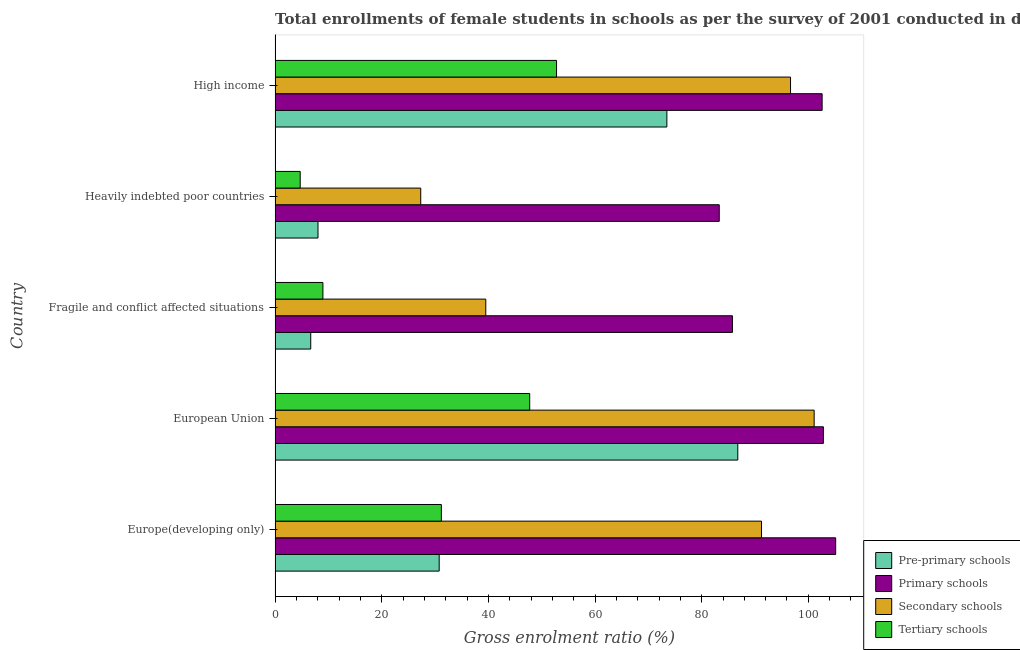How many different coloured bars are there?
Give a very brief answer. 4. How many bars are there on the 2nd tick from the top?
Keep it short and to the point. 4. What is the label of the 1st group of bars from the top?
Your answer should be very brief. High income. What is the gross enrolment ratio(female) in primary schools in Heavily indebted poor countries?
Provide a succinct answer. 83.3. Across all countries, what is the maximum gross enrolment ratio(female) in primary schools?
Give a very brief answer. 105.13. Across all countries, what is the minimum gross enrolment ratio(female) in tertiary schools?
Give a very brief answer. 4.71. In which country was the gross enrolment ratio(female) in primary schools minimum?
Give a very brief answer. Heavily indebted poor countries. What is the total gross enrolment ratio(female) in pre-primary schools in the graph?
Your response must be concise. 205.76. What is the difference between the gross enrolment ratio(female) in pre-primary schools in Fragile and conflict affected situations and that in Heavily indebted poor countries?
Offer a very short reply. -1.36. What is the difference between the gross enrolment ratio(female) in pre-primary schools in Heavily indebted poor countries and the gross enrolment ratio(female) in primary schools in European Union?
Your response must be concise. -94.78. What is the average gross enrolment ratio(female) in secondary schools per country?
Offer a very short reply. 71.16. What is the difference between the gross enrolment ratio(female) in primary schools and gross enrolment ratio(female) in pre-primary schools in Fragile and conflict affected situations?
Ensure brevity in your answer.  79.08. In how many countries, is the gross enrolment ratio(female) in primary schools greater than 88 %?
Make the answer very short. 3. What is the ratio of the gross enrolment ratio(female) in primary schools in Europe(developing only) to that in Fragile and conflict affected situations?
Your answer should be compact. 1.23. Is the gross enrolment ratio(female) in pre-primary schools in European Union less than that in Fragile and conflict affected situations?
Offer a very short reply. No. Is the difference between the gross enrolment ratio(female) in tertiary schools in Heavily indebted poor countries and High income greater than the difference between the gross enrolment ratio(female) in pre-primary schools in Heavily indebted poor countries and High income?
Offer a very short reply. Yes. What is the difference between the highest and the second highest gross enrolment ratio(female) in tertiary schools?
Give a very brief answer. 5.03. What is the difference between the highest and the lowest gross enrolment ratio(female) in pre-primary schools?
Ensure brevity in your answer.  80.09. Is the sum of the gross enrolment ratio(female) in primary schools in Fragile and conflict affected situations and Heavily indebted poor countries greater than the maximum gross enrolment ratio(female) in pre-primary schools across all countries?
Give a very brief answer. Yes. Is it the case that in every country, the sum of the gross enrolment ratio(female) in secondary schools and gross enrolment ratio(female) in primary schools is greater than the sum of gross enrolment ratio(female) in tertiary schools and gross enrolment ratio(female) in pre-primary schools?
Your answer should be compact. Yes. What does the 2nd bar from the top in Fragile and conflict affected situations represents?
Your answer should be compact. Secondary schools. What does the 2nd bar from the bottom in High income represents?
Keep it short and to the point. Primary schools. Are all the bars in the graph horizontal?
Provide a short and direct response. Yes. What is the difference between two consecutive major ticks on the X-axis?
Keep it short and to the point. 20. Are the values on the major ticks of X-axis written in scientific E-notation?
Offer a very short reply. No. Does the graph contain any zero values?
Provide a short and direct response. No. Does the graph contain grids?
Ensure brevity in your answer.  No. How are the legend labels stacked?
Your answer should be compact. Vertical. What is the title of the graph?
Offer a very short reply. Total enrollments of female students in schools as per the survey of 2001 conducted in different countries. Does "UNHCR" appear as one of the legend labels in the graph?
Offer a very short reply. No. What is the label or title of the X-axis?
Your answer should be very brief. Gross enrolment ratio (%). What is the Gross enrolment ratio (%) of Pre-primary schools in Europe(developing only)?
Give a very brief answer. 30.78. What is the Gross enrolment ratio (%) of Primary schools in Europe(developing only)?
Offer a terse response. 105.13. What is the Gross enrolment ratio (%) of Secondary schools in Europe(developing only)?
Make the answer very short. 91.22. What is the Gross enrolment ratio (%) of Tertiary schools in Europe(developing only)?
Provide a succinct answer. 31.18. What is the Gross enrolment ratio (%) of Pre-primary schools in European Union?
Give a very brief answer. 86.77. What is the Gross enrolment ratio (%) in Primary schools in European Union?
Offer a terse response. 102.83. What is the Gross enrolment ratio (%) of Secondary schools in European Union?
Your answer should be compact. 101.09. What is the Gross enrolment ratio (%) of Tertiary schools in European Union?
Offer a very short reply. 47.75. What is the Gross enrolment ratio (%) in Pre-primary schools in Fragile and conflict affected situations?
Your response must be concise. 6.69. What is the Gross enrolment ratio (%) in Primary schools in Fragile and conflict affected situations?
Offer a very short reply. 85.77. What is the Gross enrolment ratio (%) in Secondary schools in Fragile and conflict affected situations?
Your answer should be very brief. 39.51. What is the Gross enrolment ratio (%) in Tertiary schools in Fragile and conflict affected situations?
Offer a very short reply. 8.97. What is the Gross enrolment ratio (%) in Pre-primary schools in Heavily indebted poor countries?
Offer a very short reply. 8.05. What is the Gross enrolment ratio (%) of Primary schools in Heavily indebted poor countries?
Your response must be concise. 83.3. What is the Gross enrolment ratio (%) of Secondary schools in Heavily indebted poor countries?
Make the answer very short. 27.31. What is the Gross enrolment ratio (%) in Tertiary schools in Heavily indebted poor countries?
Make the answer very short. 4.71. What is the Gross enrolment ratio (%) of Pre-primary schools in High income?
Offer a very short reply. 73.47. What is the Gross enrolment ratio (%) in Primary schools in High income?
Provide a short and direct response. 102.59. What is the Gross enrolment ratio (%) in Secondary schools in High income?
Provide a succinct answer. 96.66. What is the Gross enrolment ratio (%) in Tertiary schools in High income?
Make the answer very short. 52.78. Across all countries, what is the maximum Gross enrolment ratio (%) of Pre-primary schools?
Ensure brevity in your answer.  86.77. Across all countries, what is the maximum Gross enrolment ratio (%) in Primary schools?
Your answer should be very brief. 105.13. Across all countries, what is the maximum Gross enrolment ratio (%) in Secondary schools?
Provide a succinct answer. 101.09. Across all countries, what is the maximum Gross enrolment ratio (%) of Tertiary schools?
Offer a very short reply. 52.78. Across all countries, what is the minimum Gross enrolment ratio (%) of Pre-primary schools?
Your answer should be very brief. 6.69. Across all countries, what is the minimum Gross enrolment ratio (%) of Primary schools?
Provide a short and direct response. 83.3. Across all countries, what is the minimum Gross enrolment ratio (%) of Secondary schools?
Keep it short and to the point. 27.31. Across all countries, what is the minimum Gross enrolment ratio (%) of Tertiary schools?
Your response must be concise. 4.71. What is the total Gross enrolment ratio (%) of Pre-primary schools in the graph?
Make the answer very short. 205.76. What is the total Gross enrolment ratio (%) of Primary schools in the graph?
Give a very brief answer. 479.61. What is the total Gross enrolment ratio (%) in Secondary schools in the graph?
Keep it short and to the point. 355.81. What is the total Gross enrolment ratio (%) in Tertiary schools in the graph?
Ensure brevity in your answer.  145.4. What is the difference between the Gross enrolment ratio (%) of Pre-primary schools in Europe(developing only) and that in European Union?
Your answer should be very brief. -56. What is the difference between the Gross enrolment ratio (%) of Primary schools in Europe(developing only) and that in European Union?
Your answer should be very brief. 2.3. What is the difference between the Gross enrolment ratio (%) in Secondary schools in Europe(developing only) and that in European Union?
Give a very brief answer. -9.87. What is the difference between the Gross enrolment ratio (%) of Tertiary schools in Europe(developing only) and that in European Union?
Offer a terse response. -16.57. What is the difference between the Gross enrolment ratio (%) in Pre-primary schools in Europe(developing only) and that in Fragile and conflict affected situations?
Your answer should be compact. 24.09. What is the difference between the Gross enrolment ratio (%) of Primary schools in Europe(developing only) and that in Fragile and conflict affected situations?
Keep it short and to the point. 19.36. What is the difference between the Gross enrolment ratio (%) of Secondary schools in Europe(developing only) and that in Fragile and conflict affected situations?
Provide a short and direct response. 51.71. What is the difference between the Gross enrolment ratio (%) in Tertiary schools in Europe(developing only) and that in Fragile and conflict affected situations?
Give a very brief answer. 22.21. What is the difference between the Gross enrolment ratio (%) of Pre-primary schools in Europe(developing only) and that in Heavily indebted poor countries?
Your answer should be compact. 22.73. What is the difference between the Gross enrolment ratio (%) of Primary schools in Europe(developing only) and that in Heavily indebted poor countries?
Your response must be concise. 21.83. What is the difference between the Gross enrolment ratio (%) in Secondary schools in Europe(developing only) and that in Heavily indebted poor countries?
Ensure brevity in your answer.  63.91. What is the difference between the Gross enrolment ratio (%) of Tertiary schools in Europe(developing only) and that in Heavily indebted poor countries?
Make the answer very short. 26.47. What is the difference between the Gross enrolment ratio (%) of Pre-primary schools in Europe(developing only) and that in High income?
Your response must be concise. -42.7. What is the difference between the Gross enrolment ratio (%) in Primary schools in Europe(developing only) and that in High income?
Keep it short and to the point. 2.54. What is the difference between the Gross enrolment ratio (%) of Secondary schools in Europe(developing only) and that in High income?
Offer a terse response. -5.44. What is the difference between the Gross enrolment ratio (%) of Tertiary schools in Europe(developing only) and that in High income?
Give a very brief answer. -21.6. What is the difference between the Gross enrolment ratio (%) in Pre-primary schools in European Union and that in Fragile and conflict affected situations?
Your answer should be compact. 80.09. What is the difference between the Gross enrolment ratio (%) in Primary schools in European Union and that in Fragile and conflict affected situations?
Provide a succinct answer. 17.06. What is the difference between the Gross enrolment ratio (%) in Secondary schools in European Union and that in Fragile and conflict affected situations?
Give a very brief answer. 61.58. What is the difference between the Gross enrolment ratio (%) of Tertiary schools in European Union and that in Fragile and conflict affected situations?
Ensure brevity in your answer.  38.78. What is the difference between the Gross enrolment ratio (%) of Pre-primary schools in European Union and that in Heavily indebted poor countries?
Provide a succinct answer. 78.72. What is the difference between the Gross enrolment ratio (%) of Primary schools in European Union and that in Heavily indebted poor countries?
Provide a short and direct response. 19.53. What is the difference between the Gross enrolment ratio (%) in Secondary schools in European Union and that in Heavily indebted poor countries?
Offer a terse response. 73.78. What is the difference between the Gross enrolment ratio (%) of Tertiary schools in European Union and that in Heavily indebted poor countries?
Keep it short and to the point. 43.04. What is the difference between the Gross enrolment ratio (%) of Pre-primary schools in European Union and that in High income?
Provide a short and direct response. 13.3. What is the difference between the Gross enrolment ratio (%) of Primary schools in European Union and that in High income?
Your answer should be compact. 0.24. What is the difference between the Gross enrolment ratio (%) in Secondary schools in European Union and that in High income?
Your answer should be very brief. 4.43. What is the difference between the Gross enrolment ratio (%) in Tertiary schools in European Union and that in High income?
Your answer should be compact. -5.03. What is the difference between the Gross enrolment ratio (%) of Pre-primary schools in Fragile and conflict affected situations and that in Heavily indebted poor countries?
Your response must be concise. -1.36. What is the difference between the Gross enrolment ratio (%) of Primary schools in Fragile and conflict affected situations and that in Heavily indebted poor countries?
Offer a terse response. 2.47. What is the difference between the Gross enrolment ratio (%) of Secondary schools in Fragile and conflict affected situations and that in Heavily indebted poor countries?
Give a very brief answer. 12.2. What is the difference between the Gross enrolment ratio (%) of Tertiary schools in Fragile and conflict affected situations and that in Heavily indebted poor countries?
Offer a very short reply. 4.26. What is the difference between the Gross enrolment ratio (%) of Pre-primary schools in Fragile and conflict affected situations and that in High income?
Keep it short and to the point. -66.79. What is the difference between the Gross enrolment ratio (%) in Primary schools in Fragile and conflict affected situations and that in High income?
Provide a succinct answer. -16.82. What is the difference between the Gross enrolment ratio (%) of Secondary schools in Fragile and conflict affected situations and that in High income?
Your answer should be very brief. -57.15. What is the difference between the Gross enrolment ratio (%) of Tertiary schools in Fragile and conflict affected situations and that in High income?
Provide a succinct answer. -43.81. What is the difference between the Gross enrolment ratio (%) of Pre-primary schools in Heavily indebted poor countries and that in High income?
Offer a terse response. -65.43. What is the difference between the Gross enrolment ratio (%) in Primary schools in Heavily indebted poor countries and that in High income?
Your answer should be compact. -19.29. What is the difference between the Gross enrolment ratio (%) of Secondary schools in Heavily indebted poor countries and that in High income?
Your response must be concise. -69.35. What is the difference between the Gross enrolment ratio (%) in Tertiary schools in Heavily indebted poor countries and that in High income?
Your response must be concise. -48.07. What is the difference between the Gross enrolment ratio (%) in Pre-primary schools in Europe(developing only) and the Gross enrolment ratio (%) in Primary schools in European Union?
Your response must be concise. -72.05. What is the difference between the Gross enrolment ratio (%) in Pre-primary schools in Europe(developing only) and the Gross enrolment ratio (%) in Secondary schools in European Union?
Make the answer very short. -70.32. What is the difference between the Gross enrolment ratio (%) in Pre-primary schools in Europe(developing only) and the Gross enrolment ratio (%) in Tertiary schools in European Union?
Provide a short and direct response. -16.98. What is the difference between the Gross enrolment ratio (%) of Primary schools in Europe(developing only) and the Gross enrolment ratio (%) of Secondary schools in European Union?
Give a very brief answer. 4.03. What is the difference between the Gross enrolment ratio (%) of Primary schools in Europe(developing only) and the Gross enrolment ratio (%) of Tertiary schools in European Union?
Provide a succinct answer. 57.38. What is the difference between the Gross enrolment ratio (%) of Secondary schools in Europe(developing only) and the Gross enrolment ratio (%) of Tertiary schools in European Union?
Provide a succinct answer. 43.47. What is the difference between the Gross enrolment ratio (%) of Pre-primary schools in Europe(developing only) and the Gross enrolment ratio (%) of Primary schools in Fragile and conflict affected situations?
Provide a short and direct response. -54.99. What is the difference between the Gross enrolment ratio (%) of Pre-primary schools in Europe(developing only) and the Gross enrolment ratio (%) of Secondary schools in Fragile and conflict affected situations?
Make the answer very short. -8.74. What is the difference between the Gross enrolment ratio (%) of Pre-primary schools in Europe(developing only) and the Gross enrolment ratio (%) of Tertiary schools in Fragile and conflict affected situations?
Keep it short and to the point. 21.81. What is the difference between the Gross enrolment ratio (%) of Primary schools in Europe(developing only) and the Gross enrolment ratio (%) of Secondary schools in Fragile and conflict affected situations?
Ensure brevity in your answer.  65.61. What is the difference between the Gross enrolment ratio (%) of Primary schools in Europe(developing only) and the Gross enrolment ratio (%) of Tertiary schools in Fragile and conflict affected situations?
Make the answer very short. 96.16. What is the difference between the Gross enrolment ratio (%) of Secondary schools in Europe(developing only) and the Gross enrolment ratio (%) of Tertiary schools in Fragile and conflict affected situations?
Your response must be concise. 82.25. What is the difference between the Gross enrolment ratio (%) of Pre-primary schools in Europe(developing only) and the Gross enrolment ratio (%) of Primary schools in Heavily indebted poor countries?
Offer a very short reply. -52.52. What is the difference between the Gross enrolment ratio (%) of Pre-primary schools in Europe(developing only) and the Gross enrolment ratio (%) of Secondary schools in Heavily indebted poor countries?
Ensure brevity in your answer.  3.46. What is the difference between the Gross enrolment ratio (%) in Pre-primary schools in Europe(developing only) and the Gross enrolment ratio (%) in Tertiary schools in Heavily indebted poor countries?
Your answer should be compact. 26.06. What is the difference between the Gross enrolment ratio (%) in Primary schools in Europe(developing only) and the Gross enrolment ratio (%) in Secondary schools in Heavily indebted poor countries?
Make the answer very short. 77.81. What is the difference between the Gross enrolment ratio (%) in Primary schools in Europe(developing only) and the Gross enrolment ratio (%) in Tertiary schools in Heavily indebted poor countries?
Ensure brevity in your answer.  100.42. What is the difference between the Gross enrolment ratio (%) in Secondary schools in Europe(developing only) and the Gross enrolment ratio (%) in Tertiary schools in Heavily indebted poor countries?
Your answer should be compact. 86.51. What is the difference between the Gross enrolment ratio (%) of Pre-primary schools in Europe(developing only) and the Gross enrolment ratio (%) of Primary schools in High income?
Provide a succinct answer. -71.81. What is the difference between the Gross enrolment ratio (%) in Pre-primary schools in Europe(developing only) and the Gross enrolment ratio (%) in Secondary schools in High income?
Your answer should be compact. -65.89. What is the difference between the Gross enrolment ratio (%) of Pre-primary schools in Europe(developing only) and the Gross enrolment ratio (%) of Tertiary schools in High income?
Give a very brief answer. -22.01. What is the difference between the Gross enrolment ratio (%) of Primary schools in Europe(developing only) and the Gross enrolment ratio (%) of Secondary schools in High income?
Make the answer very short. 8.46. What is the difference between the Gross enrolment ratio (%) in Primary schools in Europe(developing only) and the Gross enrolment ratio (%) in Tertiary schools in High income?
Give a very brief answer. 52.35. What is the difference between the Gross enrolment ratio (%) in Secondary schools in Europe(developing only) and the Gross enrolment ratio (%) in Tertiary schools in High income?
Your answer should be very brief. 38.44. What is the difference between the Gross enrolment ratio (%) of Pre-primary schools in European Union and the Gross enrolment ratio (%) of Primary schools in Fragile and conflict affected situations?
Your answer should be compact. 1.01. What is the difference between the Gross enrolment ratio (%) of Pre-primary schools in European Union and the Gross enrolment ratio (%) of Secondary schools in Fragile and conflict affected situations?
Your answer should be compact. 47.26. What is the difference between the Gross enrolment ratio (%) of Pre-primary schools in European Union and the Gross enrolment ratio (%) of Tertiary schools in Fragile and conflict affected situations?
Ensure brevity in your answer.  77.81. What is the difference between the Gross enrolment ratio (%) of Primary schools in European Union and the Gross enrolment ratio (%) of Secondary schools in Fragile and conflict affected situations?
Your answer should be very brief. 63.31. What is the difference between the Gross enrolment ratio (%) of Primary schools in European Union and the Gross enrolment ratio (%) of Tertiary schools in Fragile and conflict affected situations?
Your answer should be very brief. 93.86. What is the difference between the Gross enrolment ratio (%) in Secondary schools in European Union and the Gross enrolment ratio (%) in Tertiary schools in Fragile and conflict affected situations?
Provide a succinct answer. 92.13. What is the difference between the Gross enrolment ratio (%) in Pre-primary schools in European Union and the Gross enrolment ratio (%) in Primary schools in Heavily indebted poor countries?
Your response must be concise. 3.48. What is the difference between the Gross enrolment ratio (%) of Pre-primary schools in European Union and the Gross enrolment ratio (%) of Secondary schools in Heavily indebted poor countries?
Your answer should be compact. 59.46. What is the difference between the Gross enrolment ratio (%) of Pre-primary schools in European Union and the Gross enrolment ratio (%) of Tertiary schools in Heavily indebted poor countries?
Ensure brevity in your answer.  82.06. What is the difference between the Gross enrolment ratio (%) in Primary schools in European Union and the Gross enrolment ratio (%) in Secondary schools in Heavily indebted poor countries?
Give a very brief answer. 75.51. What is the difference between the Gross enrolment ratio (%) in Primary schools in European Union and the Gross enrolment ratio (%) in Tertiary schools in Heavily indebted poor countries?
Your response must be concise. 98.12. What is the difference between the Gross enrolment ratio (%) in Secondary schools in European Union and the Gross enrolment ratio (%) in Tertiary schools in Heavily indebted poor countries?
Provide a succinct answer. 96.38. What is the difference between the Gross enrolment ratio (%) of Pre-primary schools in European Union and the Gross enrolment ratio (%) of Primary schools in High income?
Your answer should be compact. -15.81. What is the difference between the Gross enrolment ratio (%) in Pre-primary schools in European Union and the Gross enrolment ratio (%) in Secondary schools in High income?
Your response must be concise. -9.89. What is the difference between the Gross enrolment ratio (%) in Pre-primary schools in European Union and the Gross enrolment ratio (%) in Tertiary schools in High income?
Your answer should be compact. 33.99. What is the difference between the Gross enrolment ratio (%) of Primary schools in European Union and the Gross enrolment ratio (%) of Secondary schools in High income?
Keep it short and to the point. 6.16. What is the difference between the Gross enrolment ratio (%) in Primary schools in European Union and the Gross enrolment ratio (%) in Tertiary schools in High income?
Offer a very short reply. 50.04. What is the difference between the Gross enrolment ratio (%) in Secondary schools in European Union and the Gross enrolment ratio (%) in Tertiary schools in High income?
Make the answer very short. 48.31. What is the difference between the Gross enrolment ratio (%) in Pre-primary schools in Fragile and conflict affected situations and the Gross enrolment ratio (%) in Primary schools in Heavily indebted poor countries?
Give a very brief answer. -76.61. What is the difference between the Gross enrolment ratio (%) of Pre-primary schools in Fragile and conflict affected situations and the Gross enrolment ratio (%) of Secondary schools in Heavily indebted poor countries?
Offer a very short reply. -20.63. What is the difference between the Gross enrolment ratio (%) in Pre-primary schools in Fragile and conflict affected situations and the Gross enrolment ratio (%) in Tertiary schools in Heavily indebted poor countries?
Your answer should be very brief. 1.98. What is the difference between the Gross enrolment ratio (%) of Primary schools in Fragile and conflict affected situations and the Gross enrolment ratio (%) of Secondary schools in Heavily indebted poor countries?
Your response must be concise. 58.45. What is the difference between the Gross enrolment ratio (%) in Primary schools in Fragile and conflict affected situations and the Gross enrolment ratio (%) in Tertiary schools in Heavily indebted poor countries?
Give a very brief answer. 81.05. What is the difference between the Gross enrolment ratio (%) in Secondary schools in Fragile and conflict affected situations and the Gross enrolment ratio (%) in Tertiary schools in Heavily indebted poor countries?
Keep it short and to the point. 34.8. What is the difference between the Gross enrolment ratio (%) in Pre-primary schools in Fragile and conflict affected situations and the Gross enrolment ratio (%) in Primary schools in High income?
Give a very brief answer. -95.9. What is the difference between the Gross enrolment ratio (%) in Pre-primary schools in Fragile and conflict affected situations and the Gross enrolment ratio (%) in Secondary schools in High income?
Give a very brief answer. -89.98. What is the difference between the Gross enrolment ratio (%) of Pre-primary schools in Fragile and conflict affected situations and the Gross enrolment ratio (%) of Tertiary schools in High income?
Ensure brevity in your answer.  -46.1. What is the difference between the Gross enrolment ratio (%) in Primary schools in Fragile and conflict affected situations and the Gross enrolment ratio (%) in Secondary schools in High income?
Provide a succinct answer. -10.9. What is the difference between the Gross enrolment ratio (%) of Primary schools in Fragile and conflict affected situations and the Gross enrolment ratio (%) of Tertiary schools in High income?
Keep it short and to the point. 32.98. What is the difference between the Gross enrolment ratio (%) of Secondary schools in Fragile and conflict affected situations and the Gross enrolment ratio (%) of Tertiary schools in High income?
Ensure brevity in your answer.  -13.27. What is the difference between the Gross enrolment ratio (%) of Pre-primary schools in Heavily indebted poor countries and the Gross enrolment ratio (%) of Primary schools in High income?
Your response must be concise. -94.54. What is the difference between the Gross enrolment ratio (%) in Pre-primary schools in Heavily indebted poor countries and the Gross enrolment ratio (%) in Secondary schools in High income?
Make the answer very short. -88.62. What is the difference between the Gross enrolment ratio (%) in Pre-primary schools in Heavily indebted poor countries and the Gross enrolment ratio (%) in Tertiary schools in High income?
Provide a succinct answer. -44.73. What is the difference between the Gross enrolment ratio (%) in Primary schools in Heavily indebted poor countries and the Gross enrolment ratio (%) in Secondary schools in High income?
Your answer should be compact. -13.37. What is the difference between the Gross enrolment ratio (%) in Primary schools in Heavily indebted poor countries and the Gross enrolment ratio (%) in Tertiary schools in High income?
Give a very brief answer. 30.51. What is the difference between the Gross enrolment ratio (%) in Secondary schools in Heavily indebted poor countries and the Gross enrolment ratio (%) in Tertiary schools in High income?
Provide a succinct answer. -25.47. What is the average Gross enrolment ratio (%) of Pre-primary schools per country?
Offer a terse response. 41.15. What is the average Gross enrolment ratio (%) of Primary schools per country?
Give a very brief answer. 95.92. What is the average Gross enrolment ratio (%) in Secondary schools per country?
Your response must be concise. 71.16. What is the average Gross enrolment ratio (%) in Tertiary schools per country?
Your answer should be compact. 29.08. What is the difference between the Gross enrolment ratio (%) in Pre-primary schools and Gross enrolment ratio (%) in Primary schools in Europe(developing only)?
Offer a very short reply. -74.35. What is the difference between the Gross enrolment ratio (%) of Pre-primary schools and Gross enrolment ratio (%) of Secondary schools in Europe(developing only)?
Your response must be concise. -60.45. What is the difference between the Gross enrolment ratio (%) in Pre-primary schools and Gross enrolment ratio (%) in Tertiary schools in Europe(developing only)?
Your response must be concise. -0.41. What is the difference between the Gross enrolment ratio (%) in Primary schools and Gross enrolment ratio (%) in Secondary schools in Europe(developing only)?
Give a very brief answer. 13.91. What is the difference between the Gross enrolment ratio (%) of Primary schools and Gross enrolment ratio (%) of Tertiary schools in Europe(developing only)?
Offer a terse response. 73.95. What is the difference between the Gross enrolment ratio (%) of Secondary schools and Gross enrolment ratio (%) of Tertiary schools in Europe(developing only)?
Provide a short and direct response. 60.04. What is the difference between the Gross enrolment ratio (%) in Pre-primary schools and Gross enrolment ratio (%) in Primary schools in European Union?
Give a very brief answer. -16.05. What is the difference between the Gross enrolment ratio (%) in Pre-primary schools and Gross enrolment ratio (%) in Secondary schools in European Union?
Your response must be concise. -14.32. What is the difference between the Gross enrolment ratio (%) in Pre-primary schools and Gross enrolment ratio (%) in Tertiary schools in European Union?
Make the answer very short. 39.02. What is the difference between the Gross enrolment ratio (%) of Primary schools and Gross enrolment ratio (%) of Secondary schools in European Union?
Offer a terse response. 1.73. What is the difference between the Gross enrolment ratio (%) in Primary schools and Gross enrolment ratio (%) in Tertiary schools in European Union?
Provide a succinct answer. 55.07. What is the difference between the Gross enrolment ratio (%) in Secondary schools and Gross enrolment ratio (%) in Tertiary schools in European Union?
Provide a succinct answer. 53.34. What is the difference between the Gross enrolment ratio (%) in Pre-primary schools and Gross enrolment ratio (%) in Primary schools in Fragile and conflict affected situations?
Your answer should be compact. -79.08. What is the difference between the Gross enrolment ratio (%) of Pre-primary schools and Gross enrolment ratio (%) of Secondary schools in Fragile and conflict affected situations?
Offer a terse response. -32.83. What is the difference between the Gross enrolment ratio (%) in Pre-primary schools and Gross enrolment ratio (%) in Tertiary schools in Fragile and conflict affected situations?
Offer a terse response. -2.28. What is the difference between the Gross enrolment ratio (%) in Primary schools and Gross enrolment ratio (%) in Secondary schools in Fragile and conflict affected situations?
Your answer should be compact. 46.25. What is the difference between the Gross enrolment ratio (%) of Primary schools and Gross enrolment ratio (%) of Tertiary schools in Fragile and conflict affected situations?
Offer a very short reply. 76.8. What is the difference between the Gross enrolment ratio (%) of Secondary schools and Gross enrolment ratio (%) of Tertiary schools in Fragile and conflict affected situations?
Give a very brief answer. 30.55. What is the difference between the Gross enrolment ratio (%) in Pre-primary schools and Gross enrolment ratio (%) in Primary schools in Heavily indebted poor countries?
Offer a terse response. -75.25. What is the difference between the Gross enrolment ratio (%) in Pre-primary schools and Gross enrolment ratio (%) in Secondary schools in Heavily indebted poor countries?
Your answer should be compact. -19.27. What is the difference between the Gross enrolment ratio (%) of Pre-primary schools and Gross enrolment ratio (%) of Tertiary schools in Heavily indebted poor countries?
Your answer should be compact. 3.34. What is the difference between the Gross enrolment ratio (%) of Primary schools and Gross enrolment ratio (%) of Secondary schools in Heavily indebted poor countries?
Offer a terse response. 55.98. What is the difference between the Gross enrolment ratio (%) in Primary schools and Gross enrolment ratio (%) in Tertiary schools in Heavily indebted poor countries?
Your response must be concise. 78.59. What is the difference between the Gross enrolment ratio (%) in Secondary schools and Gross enrolment ratio (%) in Tertiary schools in Heavily indebted poor countries?
Your answer should be compact. 22.6. What is the difference between the Gross enrolment ratio (%) of Pre-primary schools and Gross enrolment ratio (%) of Primary schools in High income?
Your answer should be very brief. -29.11. What is the difference between the Gross enrolment ratio (%) of Pre-primary schools and Gross enrolment ratio (%) of Secondary schools in High income?
Ensure brevity in your answer.  -23.19. What is the difference between the Gross enrolment ratio (%) of Pre-primary schools and Gross enrolment ratio (%) of Tertiary schools in High income?
Make the answer very short. 20.69. What is the difference between the Gross enrolment ratio (%) of Primary schools and Gross enrolment ratio (%) of Secondary schools in High income?
Offer a terse response. 5.92. What is the difference between the Gross enrolment ratio (%) of Primary schools and Gross enrolment ratio (%) of Tertiary schools in High income?
Ensure brevity in your answer.  49.81. What is the difference between the Gross enrolment ratio (%) in Secondary schools and Gross enrolment ratio (%) in Tertiary schools in High income?
Make the answer very short. 43.88. What is the ratio of the Gross enrolment ratio (%) in Pre-primary schools in Europe(developing only) to that in European Union?
Provide a succinct answer. 0.35. What is the ratio of the Gross enrolment ratio (%) of Primary schools in Europe(developing only) to that in European Union?
Offer a very short reply. 1.02. What is the ratio of the Gross enrolment ratio (%) in Secondary schools in Europe(developing only) to that in European Union?
Make the answer very short. 0.9. What is the ratio of the Gross enrolment ratio (%) of Tertiary schools in Europe(developing only) to that in European Union?
Keep it short and to the point. 0.65. What is the ratio of the Gross enrolment ratio (%) of Pre-primary schools in Europe(developing only) to that in Fragile and conflict affected situations?
Give a very brief answer. 4.6. What is the ratio of the Gross enrolment ratio (%) in Primary schools in Europe(developing only) to that in Fragile and conflict affected situations?
Offer a very short reply. 1.23. What is the ratio of the Gross enrolment ratio (%) of Secondary schools in Europe(developing only) to that in Fragile and conflict affected situations?
Offer a very short reply. 2.31. What is the ratio of the Gross enrolment ratio (%) of Tertiary schools in Europe(developing only) to that in Fragile and conflict affected situations?
Your response must be concise. 3.48. What is the ratio of the Gross enrolment ratio (%) in Pre-primary schools in Europe(developing only) to that in Heavily indebted poor countries?
Keep it short and to the point. 3.82. What is the ratio of the Gross enrolment ratio (%) in Primary schools in Europe(developing only) to that in Heavily indebted poor countries?
Offer a very short reply. 1.26. What is the ratio of the Gross enrolment ratio (%) in Secondary schools in Europe(developing only) to that in Heavily indebted poor countries?
Give a very brief answer. 3.34. What is the ratio of the Gross enrolment ratio (%) in Tertiary schools in Europe(developing only) to that in Heavily indebted poor countries?
Your answer should be compact. 6.62. What is the ratio of the Gross enrolment ratio (%) of Pre-primary schools in Europe(developing only) to that in High income?
Provide a succinct answer. 0.42. What is the ratio of the Gross enrolment ratio (%) of Primary schools in Europe(developing only) to that in High income?
Make the answer very short. 1.02. What is the ratio of the Gross enrolment ratio (%) in Secondary schools in Europe(developing only) to that in High income?
Provide a short and direct response. 0.94. What is the ratio of the Gross enrolment ratio (%) in Tertiary schools in Europe(developing only) to that in High income?
Ensure brevity in your answer.  0.59. What is the ratio of the Gross enrolment ratio (%) of Pre-primary schools in European Union to that in Fragile and conflict affected situations?
Provide a short and direct response. 12.98. What is the ratio of the Gross enrolment ratio (%) of Primary schools in European Union to that in Fragile and conflict affected situations?
Ensure brevity in your answer.  1.2. What is the ratio of the Gross enrolment ratio (%) in Secondary schools in European Union to that in Fragile and conflict affected situations?
Offer a very short reply. 2.56. What is the ratio of the Gross enrolment ratio (%) in Tertiary schools in European Union to that in Fragile and conflict affected situations?
Offer a very short reply. 5.32. What is the ratio of the Gross enrolment ratio (%) in Pre-primary schools in European Union to that in Heavily indebted poor countries?
Keep it short and to the point. 10.78. What is the ratio of the Gross enrolment ratio (%) of Primary schools in European Union to that in Heavily indebted poor countries?
Your response must be concise. 1.23. What is the ratio of the Gross enrolment ratio (%) in Secondary schools in European Union to that in Heavily indebted poor countries?
Your answer should be very brief. 3.7. What is the ratio of the Gross enrolment ratio (%) in Tertiary schools in European Union to that in Heavily indebted poor countries?
Provide a short and direct response. 10.14. What is the ratio of the Gross enrolment ratio (%) of Pre-primary schools in European Union to that in High income?
Your response must be concise. 1.18. What is the ratio of the Gross enrolment ratio (%) in Primary schools in European Union to that in High income?
Keep it short and to the point. 1. What is the ratio of the Gross enrolment ratio (%) of Secondary schools in European Union to that in High income?
Keep it short and to the point. 1.05. What is the ratio of the Gross enrolment ratio (%) of Tertiary schools in European Union to that in High income?
Make the answer very short. 0.9. What is the ratio of the Gross enrolment ratio (%) in Pre-primary schools in Fragile and conflict affected situations to that in Heavily indebted poor countries?
Offer a very short reply. 0.83. What is the ratio of the Gross enrolment ratio (%) of Primary schools in Fragile and conflict affected situations to that in Heavily indebted poor countries?
Provide a succinct answer. 1.03. What is the ratio of the Gross enrolment ratio (%) in Secondary schools in Fragile and conflict affected situations to that in Heavily indebted poor countries?
Keep it short and to the point. 1.45. What is the ratio of the Gross enrolment ratio (%) of Tertiary schools in Fragile and conflict affected situations to that in Heavily indebted poor countries?
Your answer should be compact. 1.9. What is the ratio of the Gross enrolment ratio (%) of Pre-primary schools in Fragile and conflict affected situations to that in High income?
Make the answer very short. 0.09. What is the ratio of the Gross enrolment ratio (%) in Primary schools in Fragile and conflict affected situations to that in High income?
Make the answer very short. 0.84. What is the ratio of the Gross enrolment ratio (%) in Secondary schools in Fragile and conflict affected situations to that in High income?
Your answer should be compact. 0.41. What is the ratio of the Gross enrolment ratio (%) of Tertiary schools in Fragile and conflict affected situations to that in High income?
Offer a very short reply. 0.17. What is the ratio of the Gross enrolment ratio (%) of Pre-primary schools in Heavily indebted poor countries to that in High income?
Offer a very short reply. 0.11. What is the ratio of the Gross enrolment ratio (%) in Primary schools in Heavily indebted poor countries to that in High income?
Make the answer very short. 0.81. What is the ratio of the Gross enrolment ratio (%) of Secondary schools in Heavily indebted poor countries to that in High income?
Make the answer very short. 0.28. What is the ratio of the Gross enrolment ratio (%) in Tertiary schools in Heavily indebted poor countries to that in High income?
Your answer should be compact. 0.09. What is the difference between the highest and the second highest Gross enrolment ratio (%) in Pre-primary schools?
Ensure brevity in your answer.  13.3. What is the difference between the highest and the second highest Gross enrolment ratio (%) in Primary schools?
Give a very brief answer. 2.3. What is the difference between the highest and the second highest Gross enrolment ratio (%) of Secondary schools?
Keep it short and to the point. 4.43. What is the difference between the highest and the second highest Gross enrolment ratio (%) of Tertiary schools?
Keep it short and to the point. 5.03. What is the difference between the highest and the lowest Gross enrolment ratio (%) in Pre-primary schools?
Provide a short and direct response. 80.09. What is the difference between the highest and the lowest Gross enrolment ratio (%) in Primary schools?
Offer a very short reply. 21.83. What is the difference between the highest and the lowest Gross enrolment ratio (%) of Secondary schools?
Give a very brief answer. 73.78. What is the difference between the highest and the lowest Gross enrolment ratio (%) of Tertiary schools?
Your answer should be compact. 48.07. 